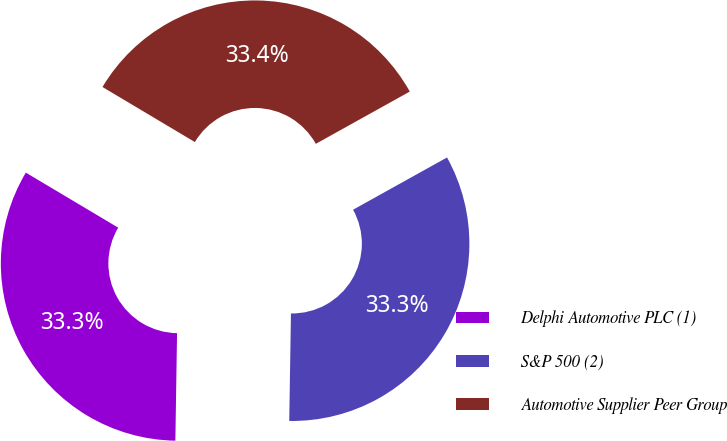Convert chart to OTSL. <chart><loc_0><loc_0><loc_500><loc_500><pie_chart><fcel>Delphi Automotive PLC (1)<fcel>S&P 500 (2)<fcel>Automotive Supplier Peer Group<nl><fcel>33.3%<fcel>33.33%<fcel>33.37%<nl></chart> 